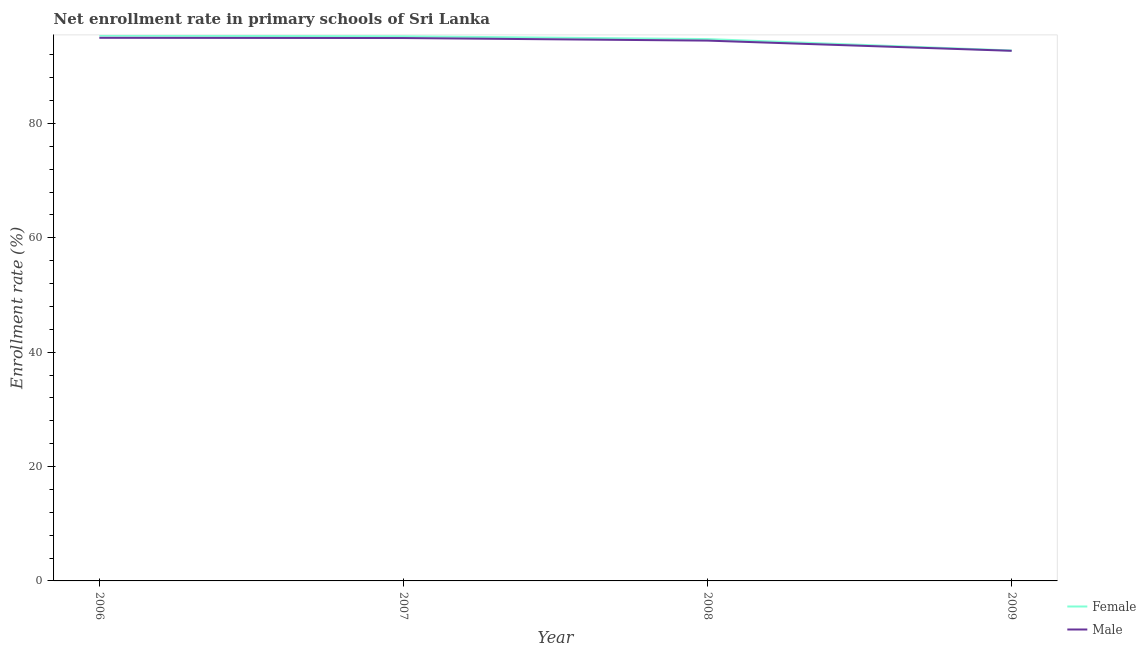Does the line corresponding to enrollment rate of female students intersect with the line corresponding to enrollment rate of male students?
Make the answer very short. No. What is the enrollment rate of male students in 2008?
Your answer should be compact. 94.48. Across all years, what is the maximum enrollment rate of female students?
Offer a terse response. 95.35. Across all years, what is the minimum enrollment rate of male students?
Provide a short and direct response. 92.69. In which year was the enrollment rate of male students maximum?
Give a very brief answer. 2006. What is the total enrollment rate of female students in the graph?
Provide a succinct answer. 378.08. What is the difference between the enrollment rate of male students in 2008 and that in 2009?
Your answer should be very brief. 1.78. What is the difference between the enrollment rate of female students in 2009 and the enrollment rate of male students in 2008?
Make the answer very short. -1.73. What is the average enrollment rate of female students per year?
Your response must be concise. 94.52. In the year 2006, what is the difference between the enrollment rate of female students and enrollment rate of male students?
Offer a very short reply. 0.38. In how many years, is the enrollment rate of male students greater than 16 %?
Provide a succinct answer. 4. What is the ratio of the enrollment rate of female students in 2007 to that in 2008?
Keep it short and to the point. 1.01. Is the enrollment rate of female students in 2008 less than that in 2009?
Keep it short and to the point. No. Is the difference between the enrollment rate of male students in 2006 and 2007 greater than the difference between the enrollment rate of female students in 2006 and 2007?
Your answer should be very brief. No. What is the difference between the highest and the second highest enrollment rate of male students?
Give a very brief answer. 0.04. What is the difference between the highest and the lowest enrollment rate of female students?
Offer a very short reply. 2.6. Is the enrollment rate of female students strictly greater than the enrollment rate of male students over the years?
Offer a terse response. Yes. Is the enrollment rate of female students strictly less than the enrollment rate of male students over the years?
Give a very brief answer. No. How many years are there in the graph?
Your answer should be very brief. 4. What is the difference between two consecutive major ticks on the Y-axis?
Your answer should be very brief. 20. Are the values on the major ticks of Y-axis written in scientific E-notation?
Your response must be concise. No. Does the graph contain any zero values?
Keep it short and to the point. No. Does the graph contain grids?
Make the answer very short. No. What is the title of the graph?
Your answer should be compact. Net enrollment rate in primary schools of Sri Lanka. What is the label or title of the X-axis?
Give a very brief answer. Year. What is the label or title of the Y-axis?
Provide a short and direct response. Enrollment rate (%). What is the Enrollment rate (%) in Female in 2006?
Offer a terse response. 95.35. What is the Enrollment rate (%) in Male in 2006?
Provide a short and direct response. 94.97. What is the Enrollment rate (%) in Female in 2007?
Your response must be concise. 95.24. What is the Enrollment rate (%) in Male in 2007?
Your response must be concise. 94.93. What is the Enrollment rate (%) of Female in 2008?
Your response must be concise. 94.74. What is the Enrollment rate (%) of Male in 2008?
Offer a terse response. 94.48. What is the Enrollment rate (%) of Female in 2009?
Your answer should be compact. 92.75. What is the Enrollment rate (%) of Male in 2009?
Offer a terse response. 92.69. Across all years, what is the maximum Enrollment rate (%) of Female?
Your answer should be compact. 95.35. Across all years, what is the maximum Enrollment rate (%) in Male?
Keep it short and to the point. 94.97. Across all years, what is the minimum Enrollment rate (%) in Female?
Your response must be concise. 92.75. Across all years, what is the minimum Enrollment rate (%) in Male?
Make the answer very short. 92.69. What is the total Enrollment rate (%) of Female in the graph?
Your answer should be compact. 378.08. What is the total Enrollment rate (%) of Male in the graph?
Offer a terse response. 377.07. What is the difference between the Enrollment rate (%) in Female in 2006 and that in 2007?
Make the answer very short. 0.11. What is the difference between the Enrollment rate (%) in Male in 2006 and that in 2007?
Keep it short and to the point. 0.04. What is the difference between the Enrollment rate (%) in Female in 2006 and that in 2008?
Keep it short and to the point. 0.6. What is the difference between the Enrollment rate (%) in Male in 2006 and that in 2008?
Provide a succinct answer. 0.49. What is the difference between the Enrollment rate (%) in Female in 2006 and that in 2009?
Keep it short and to the point. 2.6. What is the difference between the Enrollment rate (%) of Male in 2006 and that in 2009?
Your answer should be compact. 2.27. What is the difference between the Enrollment rate (%) in Female in 2007 and that in 2008?
Ensure brevity in your answer.  0.49. What is the difference between the Enrollment rate (%) in Male in 2007 and that in 2008?
Ensure brevity in your answer.  0.45. What is the difference between the Enrollment rate (%) in Female in 2007 and that in 2009?
Ensure brevity in your answer.  2.48. What is the difference between the Enrollment rate (%) of Male in 2007 and that in 2009?
Offer a very short reply. 2.23. What is the difference between the Enrollment rate (%) of Female in 2008 and that in 2009?
Your answer should be compact. 1.99. What is the difference between the Enrollment rate (%) of Male in 2008 and that in 2009?
Offer a very short reply. 1.78. What is the difference between the Enrollment rate (%) in Female in 2006 and the Enrollment rate (%) in Male in 2007?
Offer a terse response. 0.42. What is the difference between the Enrollment rate (%) in Female in 2006 and the Enrollment rate (%) in Male in 2008?
Offer a terse response. 0.87. What is the difference between the Enrollment rate (%) in Female in 2006 and the Enrollment rate (%) in Male in 2009?
Give a very brief answer. 2.65. What is the difference between the Enrollment rate (%) of Female in 2007 and the Enrollment rate (%) of Male in 2008?
Give a very brief answer. 0.76. What is the difference between the Enrollment rate (%) in Female in 2007 and the Enrollment rate (%) in Male in 2009?
Your response must be concise. 2.54. What is the difference between the Enrollment rate (%) of Female in 2008 and the Enrollment rate (%) of Male in 2009?
Keep it short and to the point. 2.05. What is the average Enrollment rate (%) in Female per year?
Your answer should be very brief. 94.52. What is the average Enrollment rate (%) of Male per year?
Your answer should be compact. 94.27. In the year 2006, what is the difference between the Enrollment rate (%) of Female and Enrollment rate (%) of Male?
Provide a succinct answer. 0.38. In the year 2007, what is the difference between the Enrollment rate (%) of Female and Enrollment rate (%) of Male?
Offer a terse response. 0.31. In the year 2008, what is the difference between the Enrollment rate (%) in Female and Enrollment rate (%) in Male?
Provide a short and direct response. 0.27. In the year 2009, what is the difference between the Enrollment rate (%) in Female and Enrollment rate (%) in Male?
Make the answer very short. 0.06. What is the ratio of the Enrollment rate (%) in Female in 2006 to that in 2007?
Your response must be concise. 1. What is the ratio of the Enrollment rate (%) of Male in 2006 to that in 2007?
Your answer should be very brief. 1. What is the ratio of the Enrollment rate (%) of Female in 2006 to that in 2008?
Keep it short and to the point. 1.01. What is the ratio of the Enrollment rate (%) of Female in 2006 to that in 2009?
Your response must be concise. 1.03. What is the ratio of the Enrollment rate (%) of Male in 2006 to that in 2009?
Keep it short and to the point. 1.02. What is the ratio of the Enrollment rate (%) of Female in 2007 to that in 2009?
Your answer should be compact. 1.03. What is the ratio of the Enrollment rate (%) in Male in 2007 to that in 2009?
Your answer should be very brief. 1.02. What is the ratio of the Enrollment rate (%) of Female in 2008 to that in 2009?
Offer a terse response. 1.02. What is the ratio of the Enrollment rate (%) in Male in 2008 to that in 2009?
Make the answer very short. 1.02. What is the difference between the highest and the second highest Enrollment rate (%) in Female?
Make the answer very short. 0.11. What is the difference between the highest and the second highest Enrollment rate (%) in Male?
Make the answer very short. 0.04. What is the difference between the highest and the lowest Enrollment rate (%) in Female?
Provide a succinct answer. 2.6. What is the difference between the highest and the lowest Enrollment rate (%) of Male?
Keep it short and to the point. 2.27. 